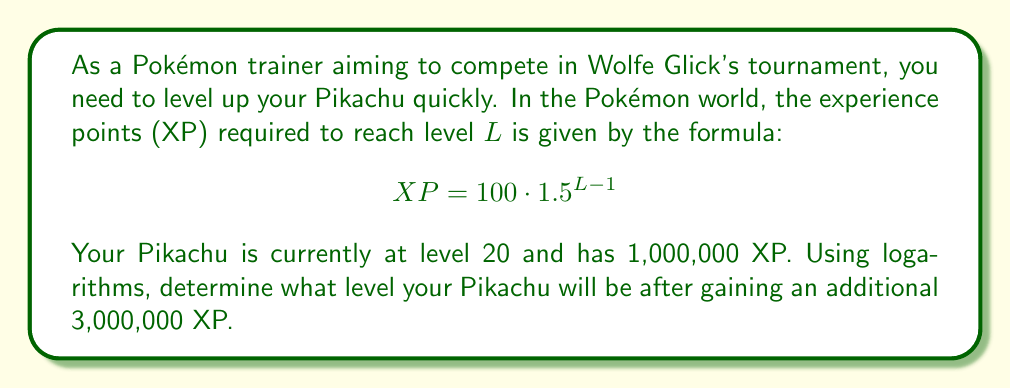Can you solve this math problem? Let's approach this step-by-step:

1) First, we need to find the total XP after gaining the additional 3,000,000 XP:
   $1,000,000 + 3,000,000 = 4,000,000$ XP

2) Now, we can use the given formula and set up our equation:
   $$ 4,000,000 = 100 \cdot 1.5^{L-1} $$

3) Divide both sides by 100:
   $$ 40,000 = 1.5^{L-1} $$

4) Now we can apply logarithms to both sides. Let's use log base 1.5:
   $$ \log_{1.5}(40,000) = \log_{1.5}(1.5^{L-1}) $$

5) The right side simplifies due to the logarithm rule $\log_a(a^x) = x$:
   $$ \log_{1.5}(40,000) = L-1 $$

6) Now we can solve for L:
   $$ L = \log_{1.5}(40,000) + 1 $$

7) To calculate this, we can use the change of base formula:
   $$ L = \frac{\ln(40,000)}{\ln(1.5)} + 1 $$

8) Using a calculator:
   $$ L \approx 32.77 + 1 = 33.77 $$

9) Since Pokémon levels are always integers, we round down to the nearest whole number.
Answer: Your Pikachu will be at level 33 after gaining an additional 3,000,000 XP. 